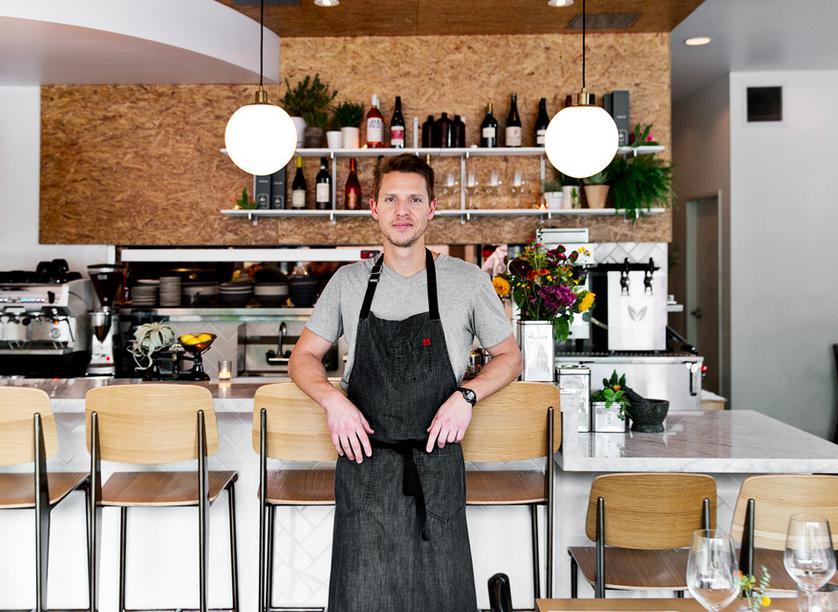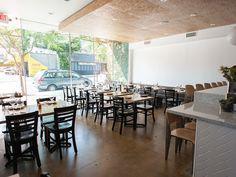The first image is the image on the left, the second image is the image on the right. For the images shown, is this caption "One image shows both bar- and table-seating inside a restaurant, while a second image shows outdoor table seating." true? Answer yes or no. No. The first image is the image on the left, the second image is the image on the right. For the images shown, is this caption "An exterior features a row of dark gray planters containing spiky green plants, in front of tables where customers are sitting, which are in front of a recessed window with a string of lights over it." true? Answer yes or no. No. 